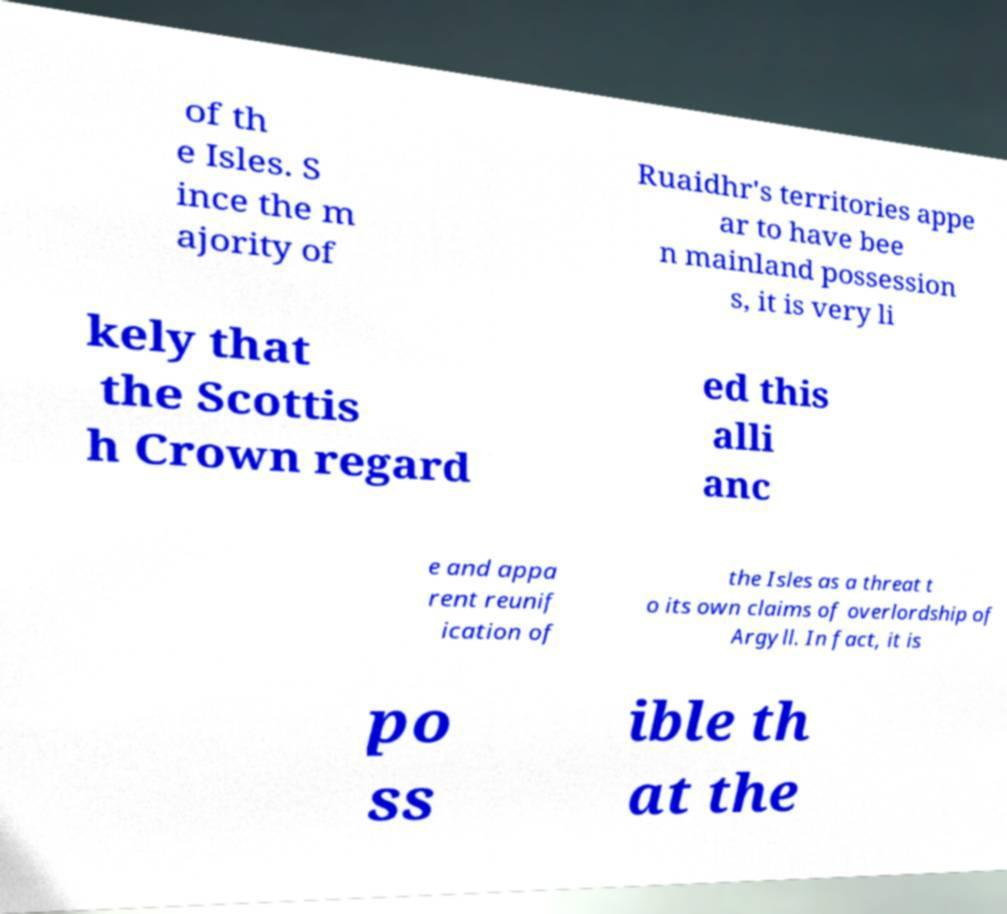Please read and relay the text visible in this image. What does it say? of th e Isles. S ince the m ajority of Ruaidhr's territories appe ar to have bee n mainland possession s, it is very li kely that the Scottis h Crown regard ed this alli anc e and appa rent reunif ication of the Isles as a threat t o its own claims of overlordship of Argyll. In fact, it is po ss ible th at the 